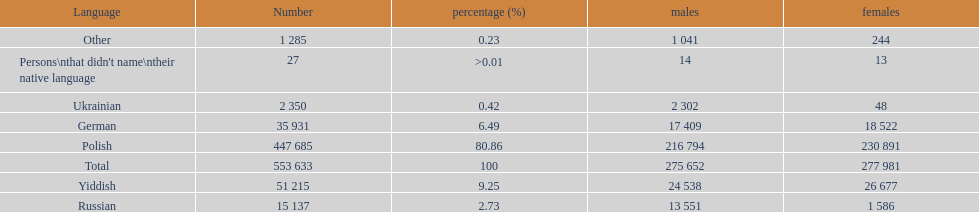How many speakers (of any language) are represented on the table ? 553 633. 